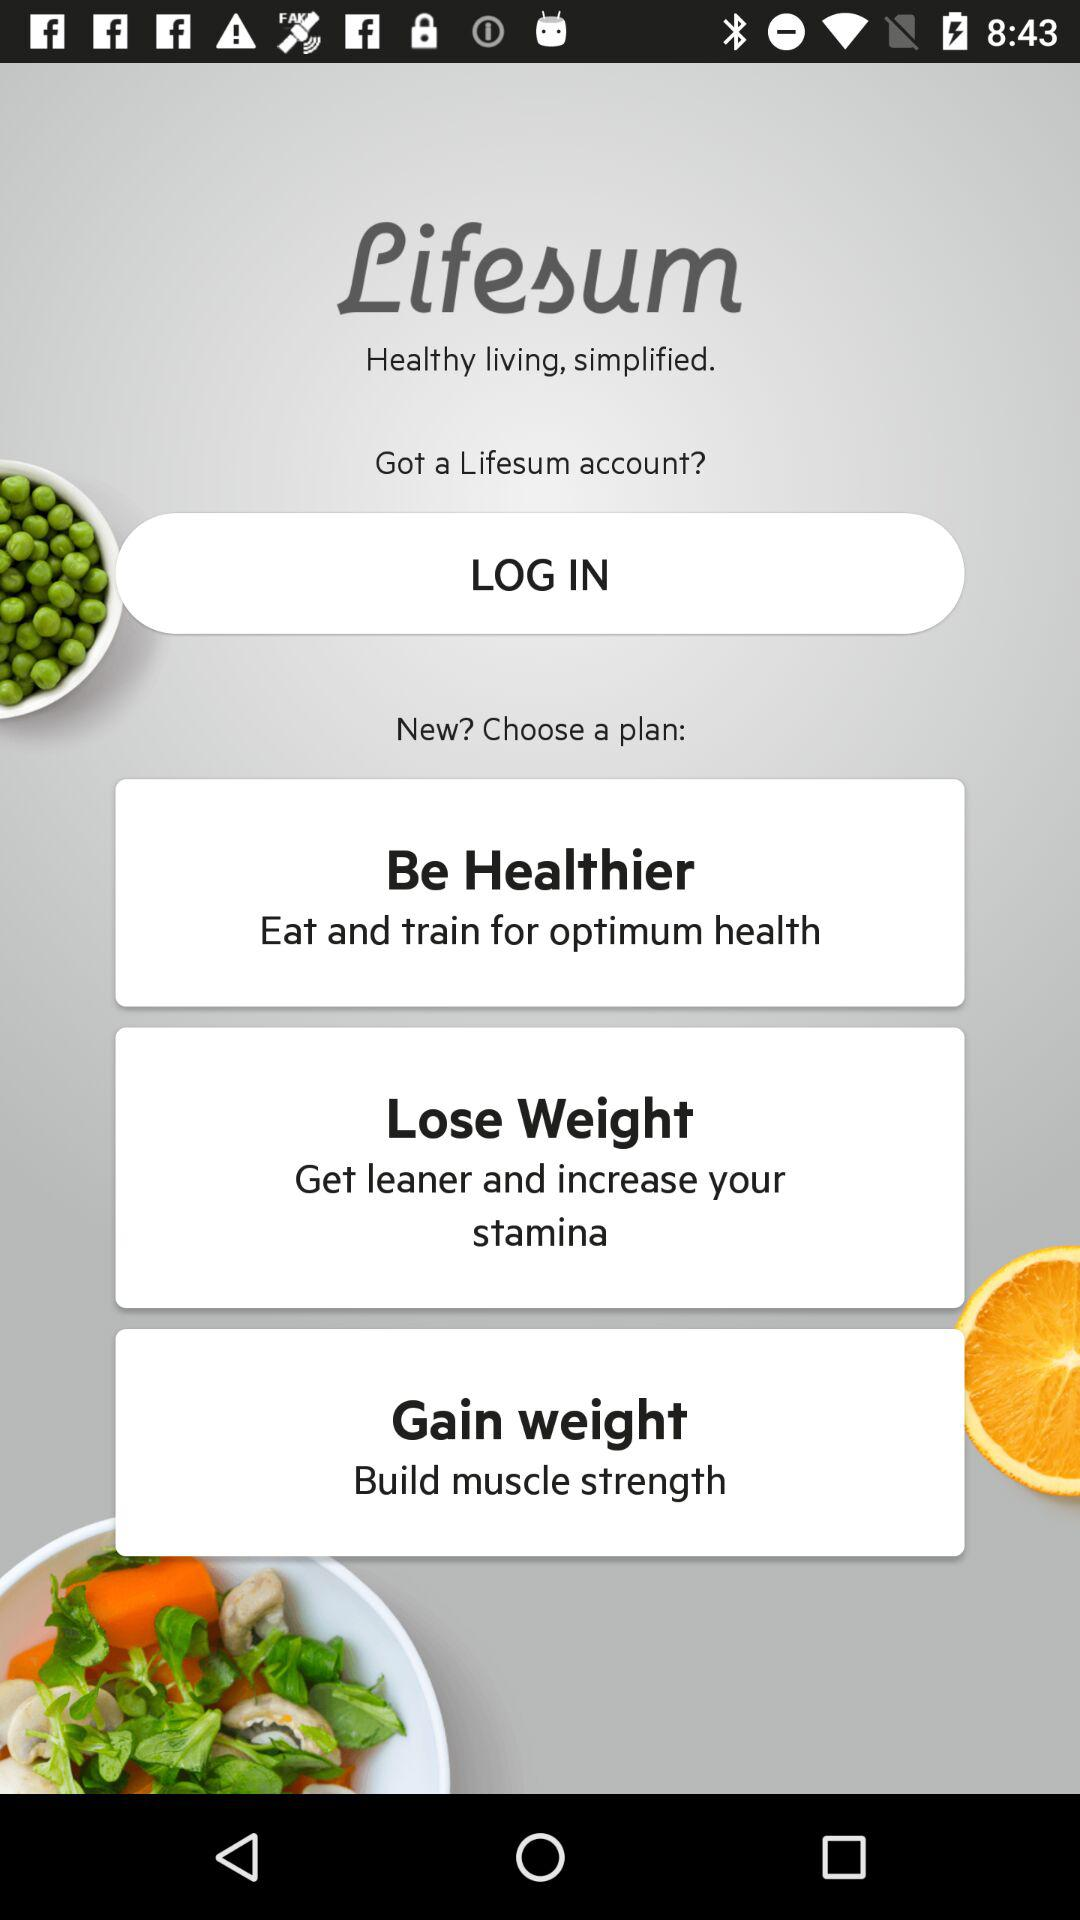What is the name of the application? The name of the application is "Lifesum". 